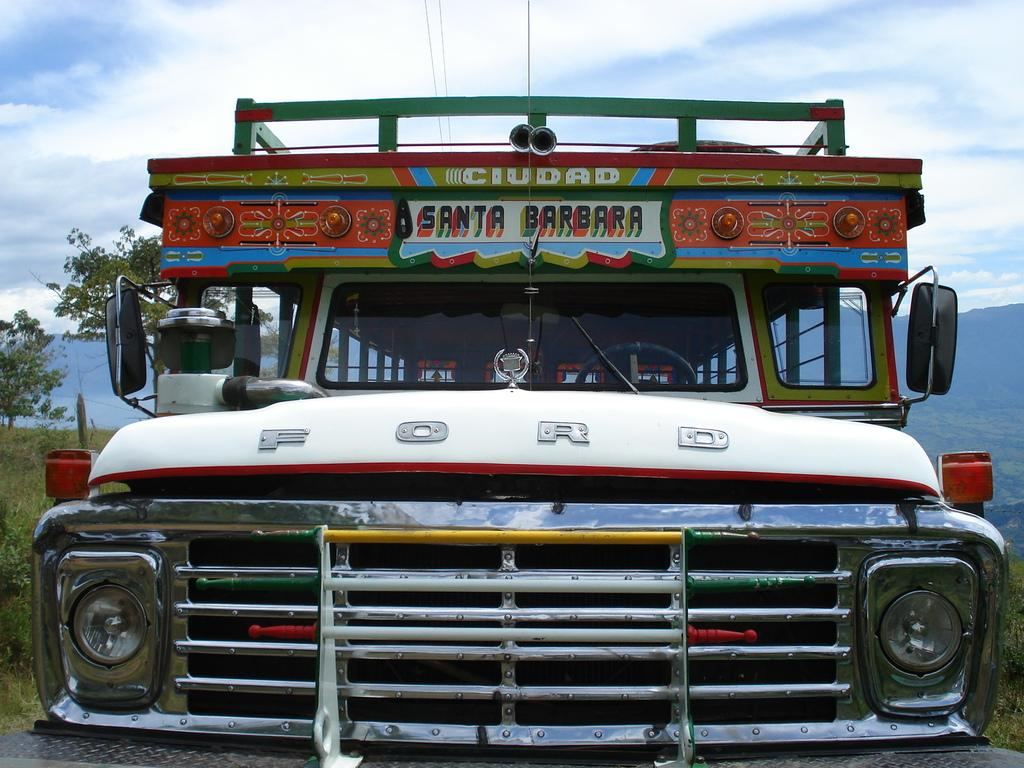What is the main subject of the image? There is a vehicle in the image. What type of natural environment is visible in the image? There is grass, trees, and hills visible in the image. What can be seen in the background of the image? The sky is visible in the background of the image, and clouds are present in the sky. What type of lettuce is being used to adjust the color of the vehicle in the image? There is no lettuce present in the image, and the color of the vehicle is not being adjusted. 